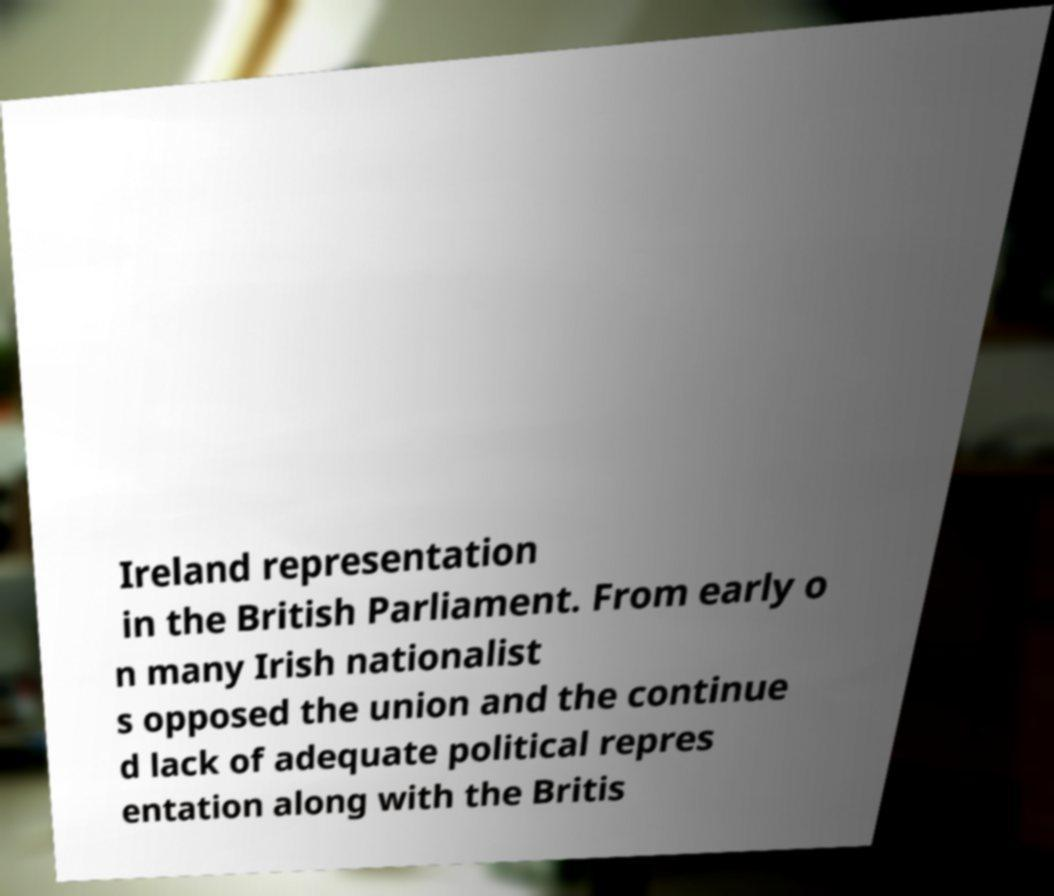Could you extract and type out the text from this image? Ireland representation in the British Parliament. From early o n many Irish nationalist s opposed the union and the continue d lack of adequate political repres entation along with the Britis 